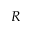Convert formula to latex. <formula><loc_0><loc_0><loc_500><loc_500>R</formula> 